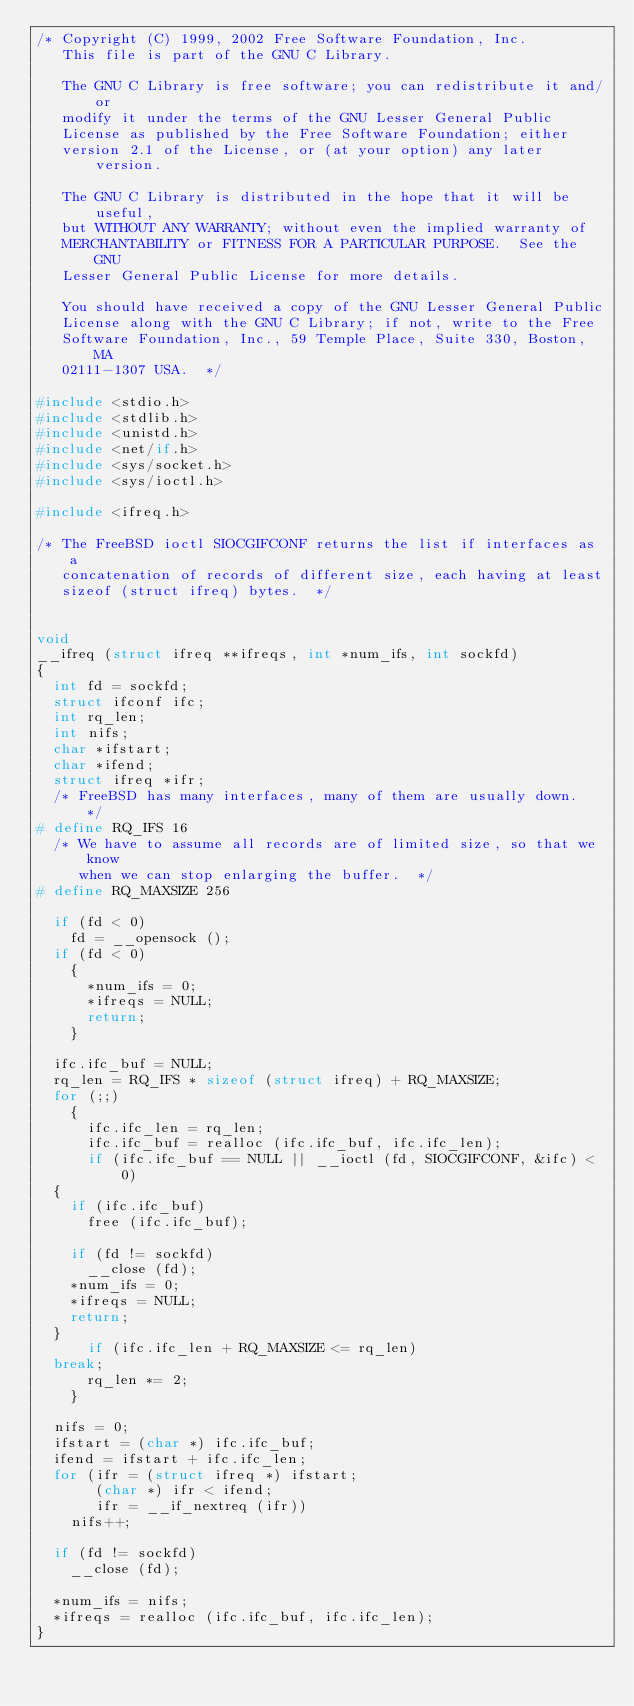<code> <loc_0><loc_0><loc_500><loc_500><_C_>/* Copyright (C) 1999, 2002 Free Software Foundation, Inc.
   This file is part of the GNU C Library.

   The GNU C Library is free software; you can redistribute it and/or
   modify it under the terms of the GNU Lesser General Public
   License as published by the Free Software Foundation; either
   version 2.1 of the License, or (at your option) any later version.

   The GNU C Library is distributed in the hope that it will be useful,
   but WITHOUT ANY WARRANTY; without even the implied warranty of
   MERCHANTABILITY or FITNESS FOR A PARTICULAR PURPOSE.  See the GNU
   Lesser General Public License for more details.

   You should have received a copy of the GNU Lesser General Public
   License along with the GNU C Library; if not, write to the Free
   Software Foundation, Inc., 59 Temple Place, Suite 330, Boston, MA
   02111-1307 USA.  */

#include <stdio.h>
#include <stdlib.h>
#include <unistd.h>
#include <net/if.h>
#include <sys/socket.h>
#include <sys/ioctl.h>

#include <ifreq.h>

/* The FreeBSD ioctl SIOCGIFCONF returns the list if interfaces as a
   concatenation of records of different size, each having at least
   sizeof (struct ifreq) bytes.  */


void
__ifreq (struct ifreq **ifreqs, int *num_ifs, int sockfd)
{
  int fd = sockfd;
  struct ifconf ifc;
  int rq_len;
  int nifs;
  char *ifstart;
  char *ifend;
  struct ifreq *ifr;
  /* FreeBSD has many interfaces, many of them are usually down.  */
# define RQ_IFS	16
  /* We have to assume all records are of limited size, so that we know
     when we can stop enlarging the buffer.  */
# define RQ_MAXSIZE 256

  if (fd < 0)
    fd = __opensock ();
  if (fd < 0)
    {
      *num_ifs = 0;
      *ifreqs = NULL;
      return;
    }

  ifc.ifc_buf = NULL;
  rq_len = RQ_IFS * sizeof (struct ifreq) + RQ_MAXSIZE;
  for (;;)
    {
      ifc.ifc_len = rq_len;
      ifc.ifc_buf = realloc (ifc.ifc_buf, ifc.ifc_len);
      if (ifc.ifc_buf == NULL || __ioctl (fd, SIOCGIFCONF, &ifc) < 0)
	{
	  if (ifc.ifc_buf)
	    free (ifc.ifc_buf);

	  if (fd != sockfd)
	    __close (fd);
	  *num_ifs = 0;
	  *ifreqs = NULL;
	  return;
	}
      if (ifc.ifc_len + RQ_MAXSIZE <= rq_len)
	break;
      rq_len *= 2;
    }

  nifs = 0;
  ifstart = (char *) ifc.ifc_buf;
  ifend = ifstart + ifc.ifc_len;
  for (ifr = (struct ifreq *) ifstart;
       (char *) ifr < ifend;
       ifr = __if_nextreq (ifr))
    nifs++;

  if (fd != sockfd)
    __close (fd);

  *num_ifs = nifs;
  *ifreqs = realloc (ifc.ifc_buf, ifc.ifc_len);
}
</code> 